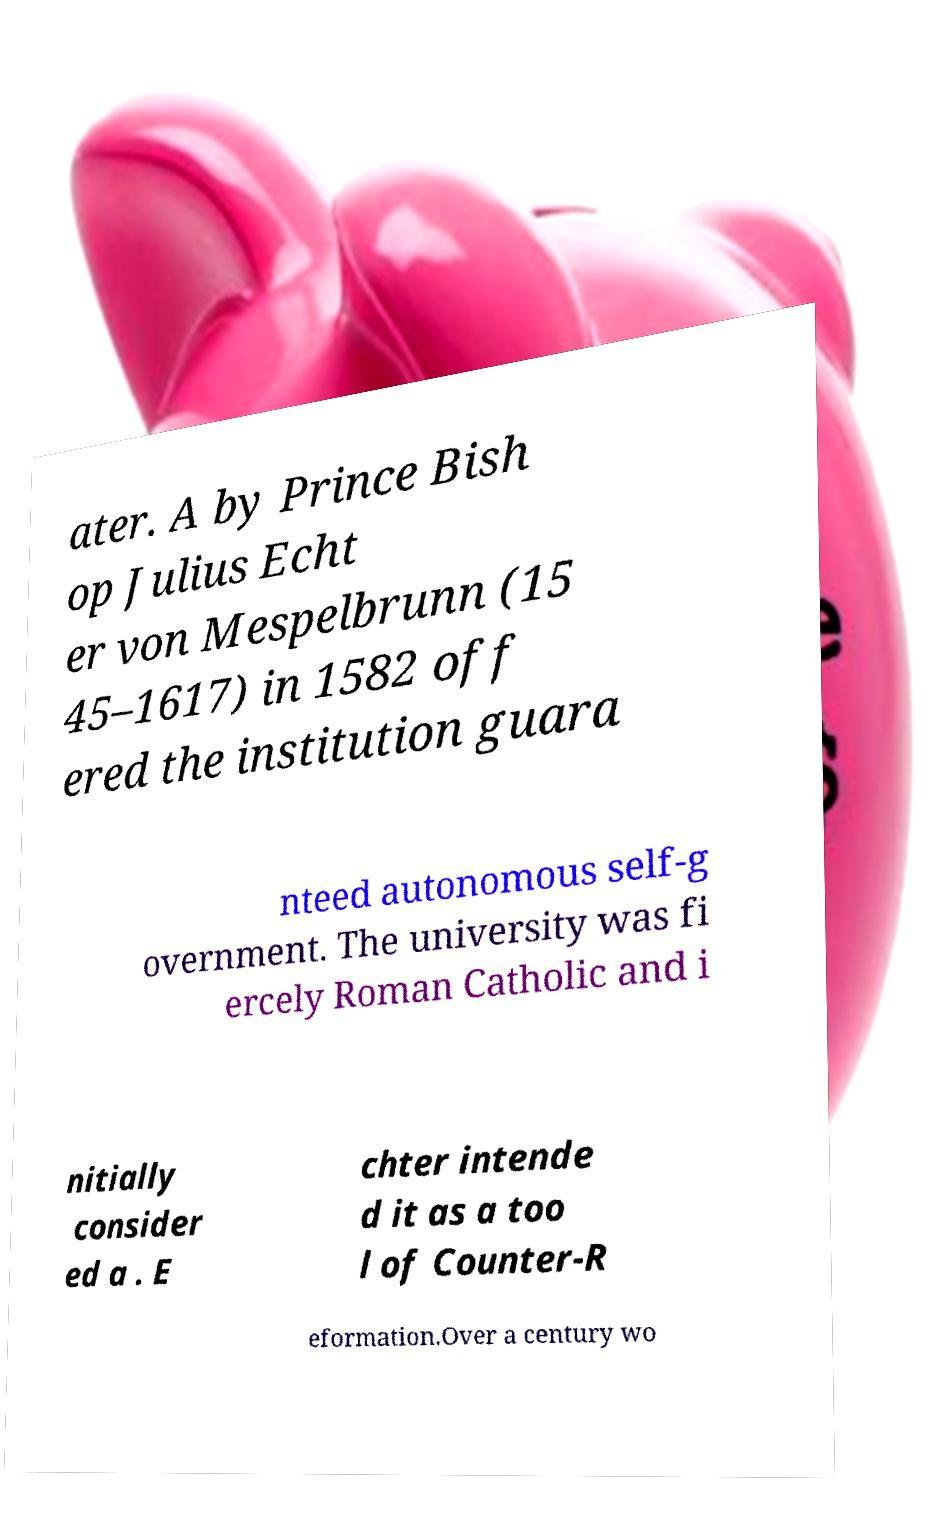Could you extract and type out the text from this image? ater. A by Prince Bish op Julius Echt er von Mespelbrunn (15 45–1617) in 1582 off ered the institution guara nteed autonomous self-g overnment. The university was fi ercely Roman Catholic and i nitially consider ed a . E chter intende d it as a too l of Counter-R eformation.Over a century wo 